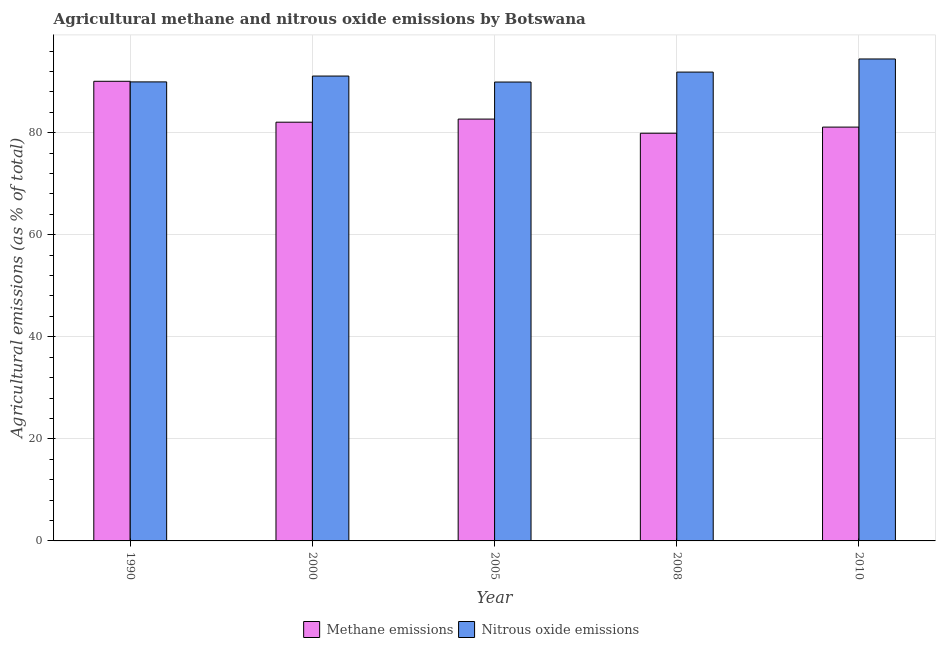How many different coloured bars are there?
Your response must be concise. 2. How many bars are there on the 2nd tick from the left?
Your response must be concise. 2. What is the label of the 3rd group of bars from the left?
Make the answer very short. 2005. What is the amount of nitrous oxide emissions in 2005?
Provide a short and direct response. 89.93. Across all years, what is the maximum amount of nitrous oxide emissions?
Provide a short and direct response. 94.45. Across all years, what is the minimum amount of methane emissions?
Offer a very short reply. 79.9. In which year was the amount of methane emissions minimum?
Offer a very short reply. 2008. What is the total amount of methane emissions in the graph?
Offer a very short reply. 415.8. What is the difference between the amount of methane emissions in 2000 and that in 2010?
Keep it short and to the point. 0.96. What is the difference between the amount of nitrous oxide emissions in 1990 and the amount of methane emissions in 2000?
Provide a short and direct response. -1.14. What is the average amount of nitrous oxide emissions per year?
Keep it short and to the point. 91.46. In the year 2005, what is the difference between the amount of nitrous oxide emissions and amount of methane emissions?
Keep it short and to the point. 0. In how many years, is the amount of methane emissions greater than 80 %?
Your answer should be very brief. 4. What is the ratio of the amount of methane emissions in 1990 to that in 2008?
Provide a succinct answer. 1.13. Is the amount of nitrous oxide emissions in 2005 less than that in 2008?
Provide a short and direct response. Yes. What is the difference between the highest and the second highest amount of methane emissions?
Keep it short and to the point. 7.41. What is the difference between the highest and the lowest amount of nitrous oxide emissions?
Your answer should be compact. 4.52. What does the 1st bar from the left in 2010 represents?
Give a very brief answer. Methane emissions. What does the 2nd bar from the right in 2010 represents?
Offer a very short reply. Methane emissions. How many bars are there?
Ensure brevity in your answer.  10. How many years are there in the graph?
Your answer should be compact. 5. Does the graph contain any zero values?
Your answer should be compact. No. Where does the legend appear in the graph?
Offer a very short reply. Bottom center. How are the legend labels stacked?
Your answer should be compact. Horizontal. What is the title of the graph?
Offer a very short reply. Agricultural methane and nitrous oxide emissions by Botswana. What is the label or title of the X-axis?
Your answer should be compact. Year. What is the label or title of the Y-axis?
Give a very brief answer. Agricultural emissions (as % of total). What is the Agricultural emissions (as % of total) in Methane emissions in 1990?
Your response must be concise. 90.08. What is the Agricultural emissions (as % of total) of Nitrous oxide emissions in 1990?
Offer a very short reply. 89.96. What is the Agricultural emissions (as % of total) of Methane emissions in 2000?
Make the answer very short. 82.06. What is the Agricultural emissions (as % of total) in Nitrous oxide emissions in 2000?
Make the answer very short. 91.1. What is the Agricultural emissions (as % of total) of Methane emissions in 2005?
Ensure brevity in your answer.  82.67. What is the Agricultural emissions (as % of total) of Nitrous oxide emissions in 2005?
Offer a very short reply. 89.93. What is the Agricultural emissions (as % of total) in Methane emissions in 2008?
Your answer should be very brief. 79.9. What is the Agricultural emissions (as % of total) in Nitrous oxide emissions in 2008?
Provide a short and direct response. 91.88. What is the Agricultural emissions (as % of total) in Methane emissions in 2010?
Ensure brevity in your answer.  81.1. What is the Agricultural emissions (as % of total) in Nitrous oxide emissions in 2010?
Give a very brief answer. 94.45. Across all years, what is the maximum Agricultural emissions (as % of total) in Methane emissions?
Offer a very short reply. 90.08. Across all years, what is the maximum Agricultural emissions (as % of total) of Nitrous oxide emissions?
Your response must be concise. 94.45. Across all years, what is the minimum Agricultural emissions (as % of total) of Methane emissions?
Your response must be concise. 79.9. Across all years, what is the minimum Agricultural emissions (as % of total) in Nitrous oxide emissions?
Your response must be concise. 89.93. What is the total Agricultural emissions (as % of total) of Methane emissions in the graph?
Your response must be concise. 415.8. What is the total Agricultural emissions (as % of total) of Nitrous oxide emissions in the graph?
Provide a short and direct response. 457.31. What is the difference between the Agricultural emissions (as % of total) in Methane emissions in 1990 and that in 2000?
Your answer should be very brief. 8.02. What is the difference between the Agricultural emissions (as % of total) of Nitrous oxide emissions in 1990 and that in 2000?
Ensure brevity in your answer.  -1.14. What is the difference between the Agricultural emissions (as % of total) of Methane emissions in 1990 and that in 2005?
Your answer should be very brief. 7.41. What is the difference between the Agricultural emissions (as % of total) in Nitrous oxide emissions in 1990 and that in 2005?
Make the answer very short. 0.03. What is the difference between the Agricultural emissions (as % of total) of Methane emissions in 1990 and that in 2008?
Offer a very short reply. 10.18. What is the difference between the Agricultural emissions (as % of total) in Nitrous oxide emissions in 1990 and that in 2008?
Keep it short and to the point. -1.92. What is the difference between the Agricultural emissions (as % of total) in Methane emissions in 1990 and that in 2010?
Keep it short and to the point. 8.98. What is the difference between the Agricultural emissions (as % of total) in Nitrous oxide emissions in 1990 and that in 2010?
Ensure brevity in your answer.  -4.49. What is the difference between the Agricultural emissions (as % of total) in Methane emissions in 2000 and that in 2005?
Make the answer very short. -0.61. What is the difference between the Agricultural emissions (as % of total) of Nitrous oxide emissions in 2000 and that in 2005?
Offer a very short reply. 1.17. What is the difference between the Agricultural emissions (as % of total) of Methane emissions in 2000 and that in 2008?
Offer a terse response. 2.16. What is the difference between the Agricultural emissions (as % of total) in Nitrous oxide emissions in 2000 and that in 2008?
Make the answer very short. -0.78. What is the difference between the Agricultural emissions (as % of total) in Methane emissions in 2000 and that in 2010?
Keep it short and to the point. 0.96. What is the difference between the Agricultural emissions (as % of total) of Nitrous oxide emissions in 2000 and that in 2010?
Your response must be concise. -3.35. What is the difference between the Agricultural emissions (as % of total) in Methane emissions in 2005 and that in 2008?
Provide a short and direct response. 2.77. What is the difference between the Agricultural emissions (as % of total) of Nitrous oxide emissions in 2005 and that in 2008?
Provide a short and direct response. -1.95. What is the difference between the Agricultural emissions (as % of total) in Methane emissions in 2005 and that in 2010?
Provide a short and direct response. 1.57. What is the difference between the Agricultural emissions (as % of total) of Nitrous oxide emissions in 2005 and that in 2010?
Your answer should be very brief. -4.52. What is the difference between the Agricultural emissions (as % of total) in Methane emissions in 2008 and that in 2010?
Provide a succinct answer. -1.2. What is the difference between the Agricultural emissions (as % of total) in Nitrous oxide emissions in 2008 and that in 2010?
Offer a very short reply. -2.57. What is the difference between the Agricultural emissions (as % of total) of Methane emissions in 1990 and the Agricultural emissions (as % of total) of Nitrous oxide emissions in 2000?
Your answer should be very brief. -1.02. What is the difference between the Agricultural emissions (as % of total) in Methane emissions in 1990 and the Agricultural emissions (as % of total) in Nitrous oxide emissions in 2005?
Offer a terse response. 0.15. What is the difference between the Agricultural emissions (as % of total) in Methane emissions in 1990 and the Agricultural emissions (as % of total) in Nitrous oxide emissions in 2008?
Your response must be concise. -1.8. What is the difference between the Agricultural emissions (as % of total) in Methane emissions in 1990 and the Agricultural emissions (as % of total) in Nitrous oxide emissions in 2010?
Provide a short and direct response. -4.37. What is the difference between the Agricultural emissions (as % of total) of Methane emissions in 2000 and the Agricultural emissions (as % of total) of Nitrous oxide emissions in 2005?
Your answer should be very brief. -7.87. What is the difference between the Agricultural emissions (as % of total) in Methane emissions in 2000 and the Agricultural emissions (as % of total) in Nitrous oxide emissions in 2008?
Offer a terse response. -9.82. What is the difference between the Agricultural emissions (as % of total) in Methane emissions in 2000 and the Agricultural emissions (as % of total) in Nitrous oxide emissions in 2010?
Your answer should be compact. -12.39. What is the difference between the Agricultural emissions (as % of total) in Methane emissions in 2005 and the Agricultural emissions (as % of total) in Nitrous oxide emissions in 2008?
Provide a short and direct response. -9.21. What is the difference between the Agricultural emissions (as % of total) of Methane emissions in 2005 and the Agricultural emissions (as % of total) of Nitrous oxide emissions in 2010?
Make the answer very short. -11.78. What is the difference between the Agricultural emissions (as % of total) in Methane emissions in 2008 and the Agricultural emissions (as % of total) in Nitrous oxide emissions in 2010?
Your answer should be compact. -14.55. What is the average Agricultural emissions (as % of total) of Methane emissions per year?
Keep it short and to the point. 83.16. What is the average Agricultural emissions (as % of total) in Nitrous oxide emissions per year?
Keep it short and to the point. 91.46. In the year 1990, what is the difference between the Agricultural emissions (as % of total) in Methane emissions and Agricultural emissions (as % of total) in Nitrous oxide emissions?
Offer a terse response. 0.12. In the year 2000, what is the difference between the Agricultural emissions (as % of total) of Methane emissions and Agricultural emissions (as % of total) of Nitrous oxide emissions?
Make the answer very short. -9.04. In the year 2005, what is the difference between the Agricultural emissions (as % of total) of Methane emissions and Agricultural emissions (as % of total) of Nitrous oxide emissions?
Provide a short and direct response. -7.26. In the year 2008, what is the difference between the Agricultural emissions (as % of total) of Methane emissions and Agricultural emissions (as % of total) of Nitrous oxide emissions?
Provide a short and direct response. -11.98. In the year 2010, what is the difference between the Agricultural emissions (as % of total) in Methane emissions and Agricultural emissions (as % of total) in Nitrous oxide emissions?
Offer a terse response. -13.35. What is the ratio of the Agricultural emissions (as % of total) of Methane emissions in 1990 to that in 2000?
Provide a short and direct response. 1.1. What is the ratio of the Agricultural emissions (as % of total) in Nitrous oxide emissions in 1990 to that in 2000?
Make the answer very short. 0.99. What is the ratio of the Agricultural emissions (as % of total) of Methane emissions in 1990 to that in 2005?
Provide a short and direct response. 1.09. What is the ratio of the Agricultural emissions (as % of total) in Methane emissions in 1990 to that in 2008?
Make the answer very short. 1.13. What is the ratio of the Agricultural emissions (as % of total) in Nitrous oxide emissions in 1990 to that in 2008?
Make the answer very short. 0.98. What is the ratio of the Agricultural emissions (as % of total) of Methane emissions in 1990 to that in 2010?
Your answer should be compact. 1.11. What is the ratio of the Agricultural emissions (as % of total) in Nitrous oxide emissions in 1990 to that in 2010?
Provide a succinct answer. 0.95. What is the ratio of the Agricultural emissions (as % of total) in Methane emissions in 2000 to that in 2005?
Make the answer very short. 0.99. What is the ratio of the Agricultural emissions (as % of total) of Methane emissions in 2000 to that in 2008?
Your response must be concise. 1.03. What is the ratio of the Agricultural emissions (as % of total) in Methane emissions in 2000 to that in 2010?
Provide a succinct answer. 1.01. What is the ratio of the Agricultural emissions (as % of total) in Nitrous oxide emissions in 2000 to that in 2010?
Give a very brief answer. 0.96. What is the ratio of the Agricultural emissions (as % of total) of Methane emissions in 2005 to that in 2008?
Make the answer very short. 1.03. What is the ratio of the Agricultural emissions (as % of total) in Nitrous oxide emissions in 2005 to that in 2008?
Keep it short and to the point. 0.98. What is the ratio of the Agricultural emissions (as % of total) of Methane emissions in 2005 to that in 2010?
Your response must be concise. 1.02. What is the ratio of the Agricultural emissions (as % of total) in Nitrous oxide emissions in 2005 to that in 2010?
Offer a terse response. 0.95. What is the ratio of the Agricultural emissions (as % of total) of Methane emissions in 2008 to that in 2010?
Your answer should be very brief. 0.99. What is the ratio of the Agricultural emissions (as % of total) in Nitrous oxide emissions in 2008 to that in 2010?
Provide a short and direct response. 0.97. What is the difference between the highest and the second highest Agricultural emissions (as % of total) of Methane emissions?
Your answer should be very brief. 7.41. What is the difference between the highest and the second highest Agricultural emissions (as % of total) of Nitrous oxide emissions?
Offer a terse response. 2.57. What is the difference between the highest and the lowest Agricultural emissions (as % of total) of Methane emissions?
Provide a short and direct response. 10.18. What is the difference between the highest and the lowest Agricultural emissions (as % of total) of Nitrous oxide emissions?
Provide a short and direct response. 4.52. 